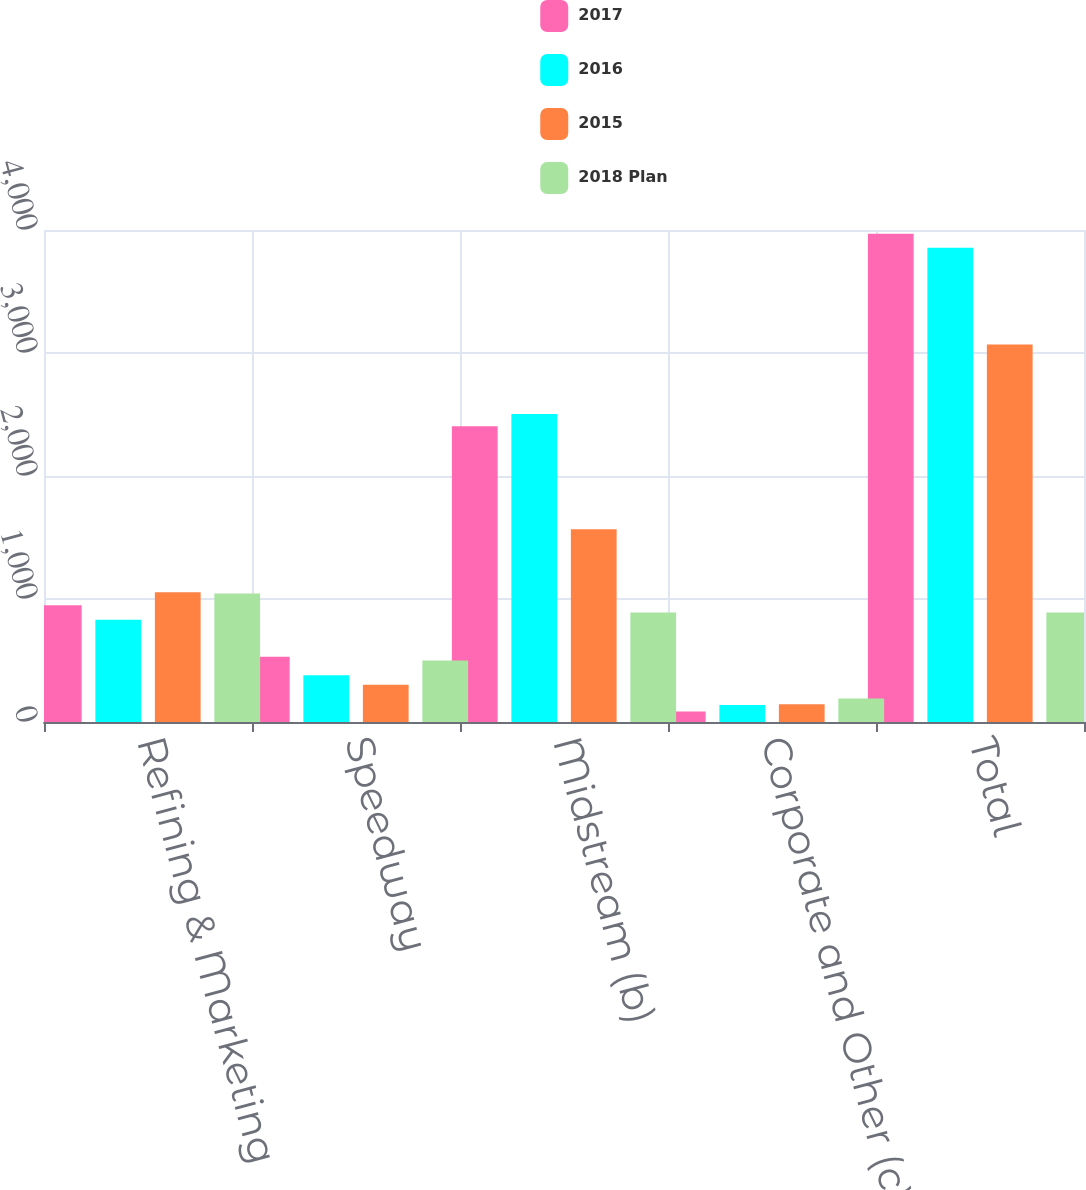<chart> <loc_0><loc_0><loc_500><loc_500><stacked_bar_chart><ecel><fcel>Refining & Marketing<fcel>Speedway<fcel>Midstream (b)<fcel>Corporate and Other (c)<fcel>Total<nl><fcel>2017<fcel>950<fcel>530<fcel>2405<fcel>85<fcel>3970<nl><fcel>2016<fcel>832<fcel>381<fcel>2505<fcel>138<fcel>3856<nl><fcel>2015<fcel>1054<fcel>303<fcel>1568<fcel>144<fcel>3069<nl><fcel>2018 Plan<fcel>1045<fcel>501<fcel>891<fcel>192<fcel>891<nl></chart> 